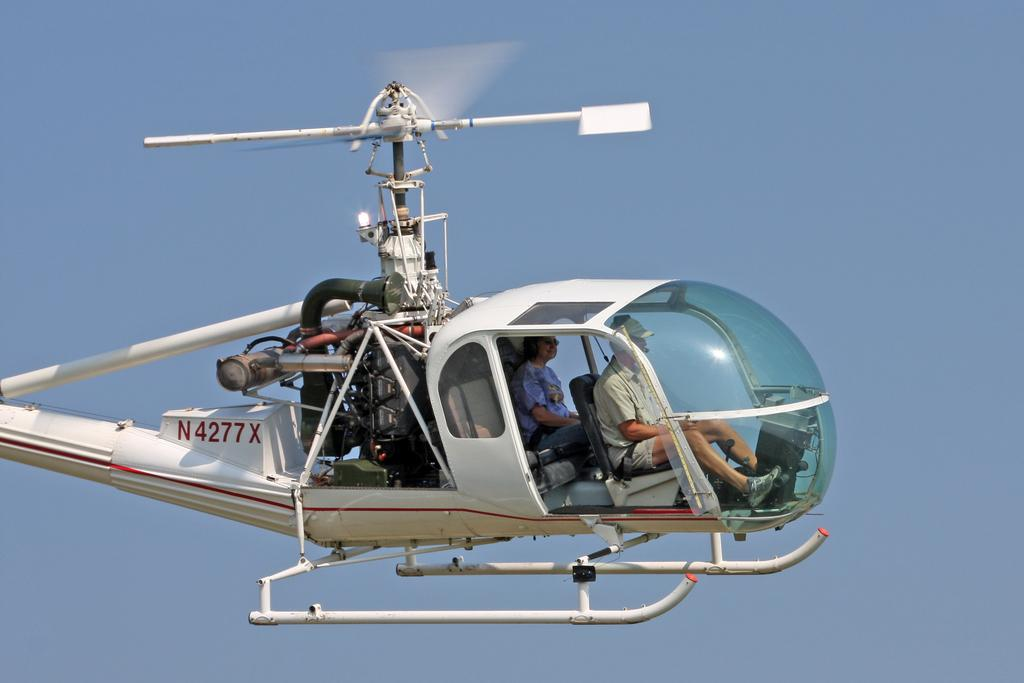Provide a one-sentence caption for the provided image. Man navigating a helicopter with the license "N4277X". 